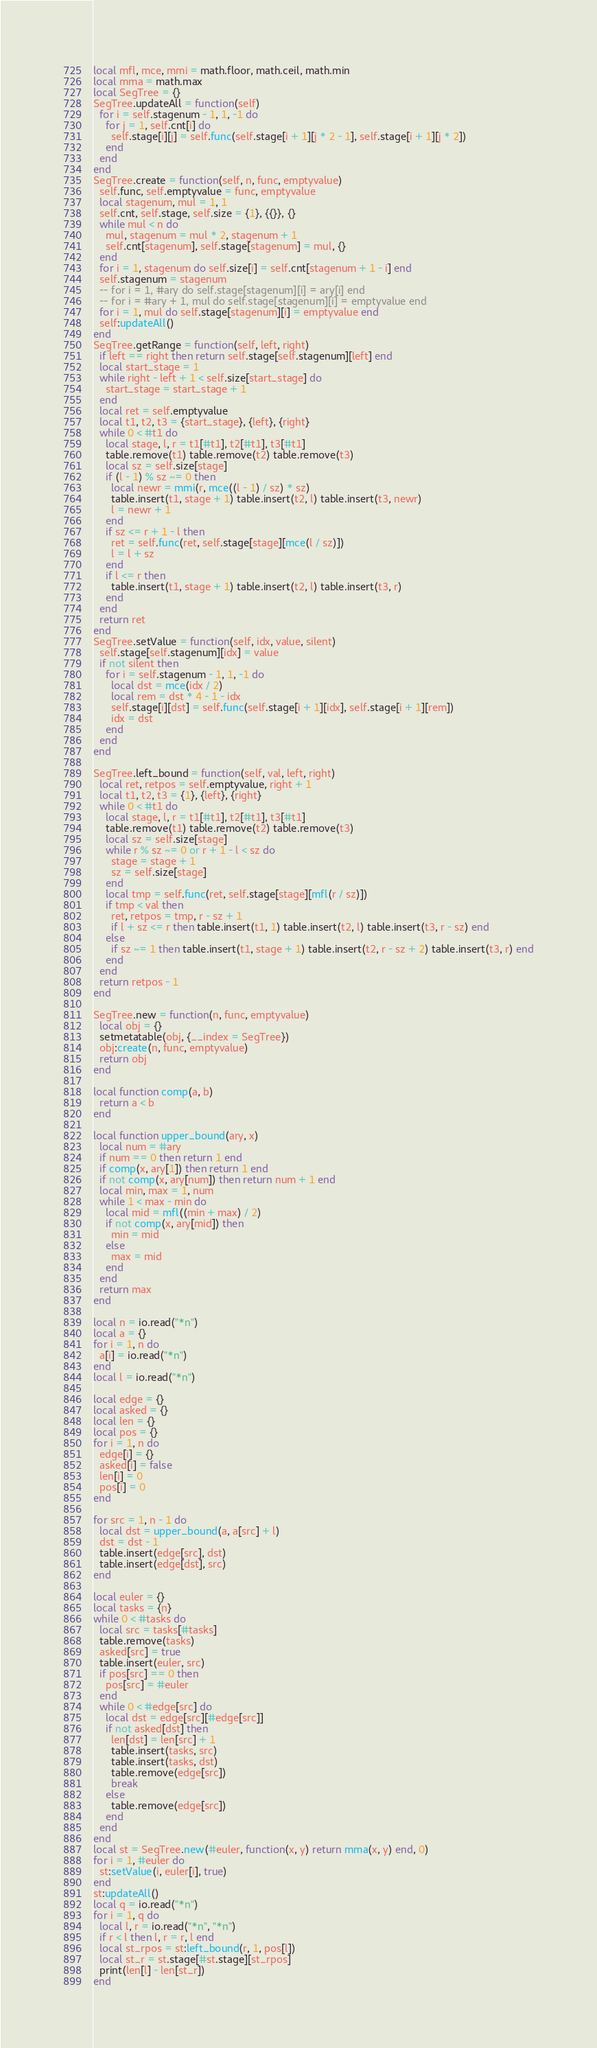Convert code to text. <code><loc_0><loc_0><loc_500><loc_500><_Lua_>local mfl, mce, mmi = math.floor, math.ceil, math.min
local mma = math.max
local SegTree = {}
SegTree.updateAll = function(self)
  for i = self.stagenum - 1, 1, -1 do
    for j = 1, self.cnt[i] do
      self.stage[i][j] = self.func(self.stage[i + 1][j * 2 - 1], self.stage[i + 1][j * 2])
    end
  end
end
SegTree.create = function(self, n, func, emptyvalue)
  self.func, self.emptyvalue = func, emptyvalue
  local stagenum, mul = 1, 1
  self.cnt, self.stage, self.size = {1}, {{}}, {}
  while mul < n do
    mul, stagenum = mul * 2, stagenum + 1
    self.cnt[stagenum], self.stage[stagenum] = mul, {}
  end
  for i = 1, stagenum do self.size[i] = self.cnt[stagenum + 1 - i] end
  self.stagenum = stagenum
  -- for i = 1, #ary do self.stage[stagenum][i] = ary[i] end
  -- for i = #ary + 1, mul do self.stage[stagenum][i] = emptyvalue end
  for i = 1, mul do self.stage[stagenum][i] = emptyvalue end
  self:updateAll()
end
SegTree.getRange = function(self, left, right)
  if left == right then return self.stage[self.stagenum][left] end
  local start_stage = 1
  while right - left + 1 < self.size[start_stage] do
    start_stage = start_stage + 1
  end
  local ret = self.emptyvalue
  local t1, t2, t3 = {start_stage}, {left}, {right}
  while 0 < #t1 do
    local stage, l, r = t1[#t1], t2[#t1], t3[#t1]
    table.remove(t1) table.remove(t2) table.remove(t3)
    local sz = self.size[stage]
    if (l - 1) % sz ~= 0 then
      local newr = mmi(r, mce((l - 1) / sz) * sz)
      table.insert(t1, stage + 1) table.insert(t2, l) table.insert(t3, newr)
      l = newr + 1
    end
    if sz <= r + 1 - l then
      ret = self.func(ret, self.stage[stage][mce(l / sz)])
      l = l + sz
    end
    if l <= r then
      table.insert(t1, stage + 1) table.insert(t2, l) table.insert(t3, r)
    end
  end
  return ret
end
SegTree.setValue = function(self, idx, value, silent)
  self.stage[self.stagenum][idx] = value
  if not silent then
    for i = self.stagenum - 1, 1, -1 do
      local dst = mce(idx / 2)
      local rem = dst * 4 - 1 - idx
      self.stage[i][dst] = self.func(self.stage[i + 1][idx], self.stage[i + 1][rem])
      idx = dst
    end
  end
end

SegTree.left_bound = function(self, val, left, right)
  local ret, retpos = self.emptyvalue, right + 1
  local t1, t2, t3 = {1}, {left}, {right}
  while 0 < #t1 do
    local stage, l, r = t1[#t1], t2[#t1], t3[#t1]
    table.remove(t1) table.remove(t2) table.remove(t3)
    local sz = self.size[stage]
    while r % sz ~= 0 or r + 1 - l < sz do
      stage = stage + 1
      sz = self.size[stage]
    end
    local tmp = self.func(ret, self.stage[stage][mfl(r / sz)])
    if tmp < val then
      ret, retpos = tmp, r - sz + 1
      if l + sz <= r then table.insert(t1, 1) table.insert(t2, l) table.insert(t3, r - sz) end
    else
      if sz ~= 1 then table.insert(t1, stage + 1) table.insert(t2, r - sz + 2) table.insert(t3, r) end
    end
  end
  return retpos - 1
end

SegTree.new = function(n, func, emptyvalue)
  local obj = {}
  setmetatable(obj, {__index = SegTree})
  obj:create(n, func, emptyvalue)
  return obj
end

local function comp(a, b)
  return a < b
end

local function upper_bound(ary, x)
  local num = #ary
  if num == 0 then return 1 end
  if comp(x, ary[1]) then return 1 end
  if not comp(x, ary[num]) then return num + 1 end
  local min, max = 1, num
  while 1 < max - min do
    local mid = mfl((min + max) / 2)
    if not comp(x, ary[mid]) then
      min = mid
    else
      max = mid
    end
  end
  return max
end

local n = io.read("*n")
local a = {}
for i = 1, n do
  a[i] = io.read("*n")
end
local l = io.read("*n")

local edge = {}
local asked = {}
local len = {}
local pos = {}
for i = 1, n do
  edge[i] = {}
  asked[i] = false
  len[i] = 0
  pos[i] = 0
end

for src = 1, n - 1 do
  local dst = upper_bound(a, a[src] + l)
  dst = dst - 1
  table.insert(edge[src], dst)
  table.insert(edge[dst], src)
end

local euler = {}
local tasks = {n}
while 0 < #tasks do
  local src = tasks[#tasks]
  table.remove(tasks)
  asked[src] = true
  table.insert(euler, src)
  if pos[src] == 0 then
    pos[src] = #euler
  end
  while 0 < #edge[src] do
    local dst = edge[src][#edge[src]]
    if not asked[dst] then
      len[dst] = len[src] + 1
      table.insert(tasks, src)
      table.insert(tasks, dst)
      table.remove(edge[src])
      break
    else
      table.remove(edge[src])
    end
  end
end
local st = SegTree.new(#euler, function(x, y) return mma(x, y) end, 0)
for i = 1, #euler do
  st:setValue(i, euler[i], true)
end
st:updateAll()
local q = io.read("*n")
for i = 1, q do
  local l, r = io.read("*n", "*n")
  if r < l then l, r = r, l end
  local st_rpos = st:left_bound(r, 1, pos[l])
  local st_r = st.stage[#st.stage][st_rpos]
  print(len[l] - len[st_r])
end
</code> 